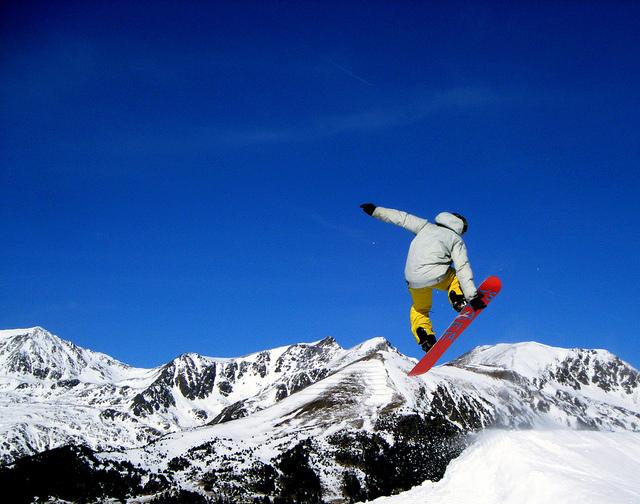Is the person on the ground?
Keep it brief. No. What color is the snowboard?
Quick response, please. Red. Does this person have a good sense of balance?
Quick response, please. Yes. 